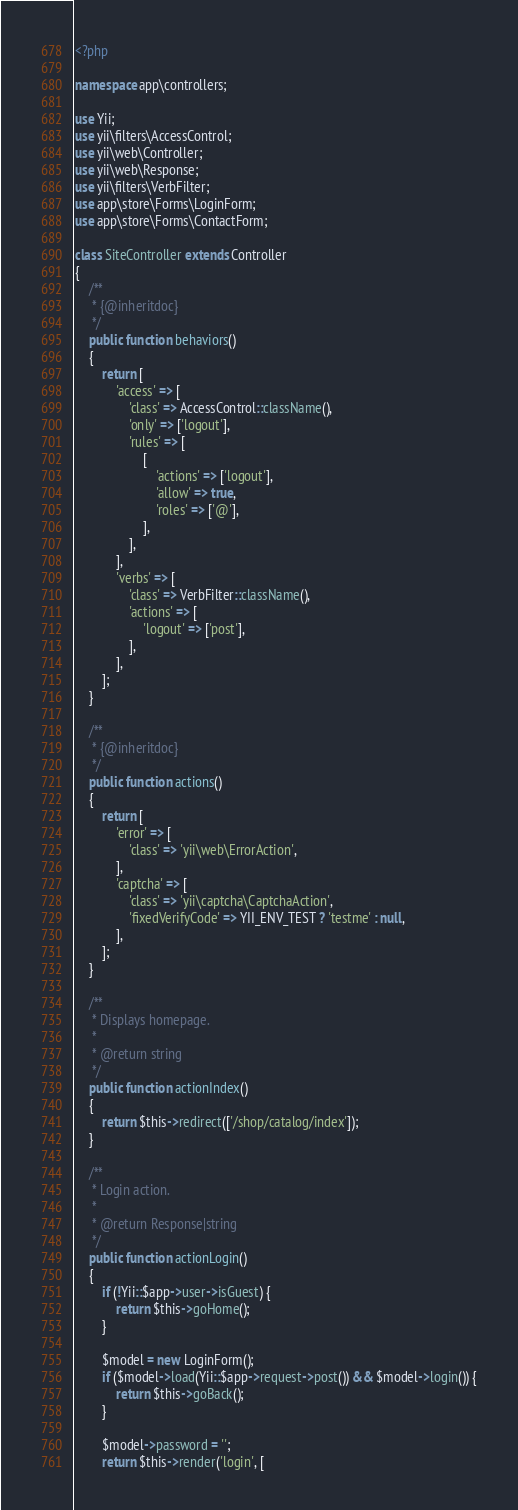<code> <loc_0><loc_0><loc_500><loc_500><_PHP_><?php

namespace app\controllers;

use Yii;
use yii\filters\AccessControl;
use yii\web\Controller;
use yii\web\Response;
use yii\filters\VerbFilter;
use app\store\Forms\LoginForm;
use app\store\Forms\ContactForm;

class SiteController extends Controller
{
    /**
     * {@inheritdoc}
     */
    public function behaviors()
    {
        return [
            'access' => [
                'class' => AccessControl::className(),
                'only' => ['logout'],
                'rules' => [
                    [
                        'actions' => ['logout'],
                        'allow' => true,
                        'roles' => ['@'],
                    ],
                ],
            ],
            'verbs' => [
                'class' => VerbFilter::className(),
                'actions' => [
                    'logout' => ['post'],
                ],
            ],
        ];
    }

    /**
     * {@inheritdoc}
     */
    public function actions()
    {
        return [
            'error' => [
                'class' => 'yii\web\ErrorAction',
            ],
            'captcha' => [
                'class' => 'yii\captcha\CaptchaAction',
                'fixedVerifyCode' => YII_ENV_TEST ? 'testme' : null,
            ],
        ];
    }

    /**
     * Displays homepage.
     *
     * @return string
     */
    public function actionIndex()
    {
        return $this->redirect(['/shop/catalog/index']);
    }

    /**
     * Login action.
     *
     * @return Response|string
     */
    public function actionLogin()
    {
        if (!Yii::$app->user->isGuest) {
            return $this->goHome();
        }

        $model = new LoginForm();
        if ($model->load(Yii::$app->request->post()) && $model->login()) {
            return $this->goBack();
        }

        $model->password = '';
        return $this->render('login', [</code> 